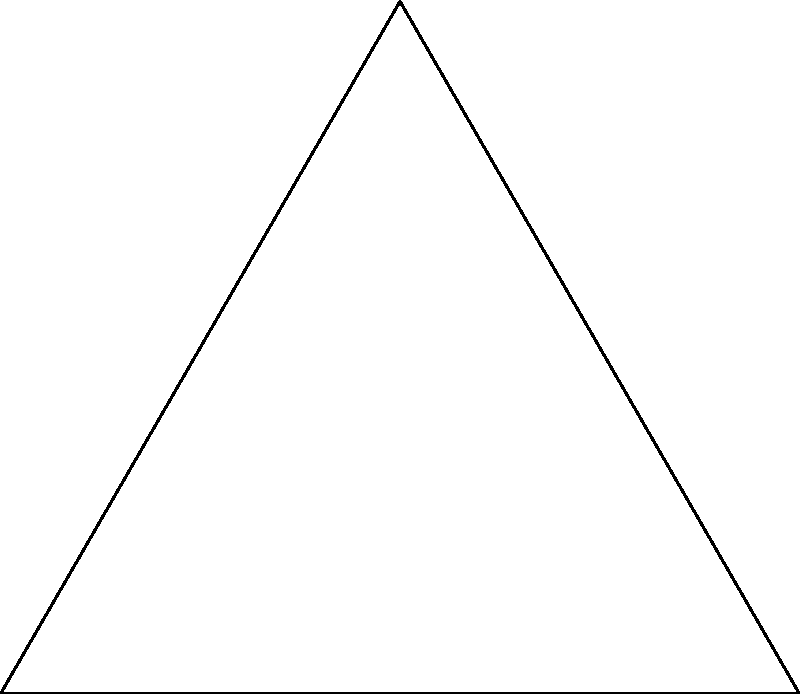In a basketball court represented by triangle ABC, three players are positioned at the vertices. Each player's defensive zone is a circle with a radius of 3 units. What is the area of the court that is covered by at least two defensive zones? To solve this problem, we'll follow these steps:

1) First, we need to calculate the area of intersection between each pair of circles:
   - Circles centered at A and B
   - Circles centered at B and C
   - Circles centered at A and C

2) The formula for the area of intersection of two circles with radius r and distance d between their centers is:

   $$A = 2r^2 \arccos(\frac{d}{2r}) - d\sqrt{r^2 - (\frac{d}{2})^2}$$

3) Let's calculate the distances:
   - AB = 6
   - BC = $\sqrt{3^2 + 5.2^2} \approx 6$
   - AC = $\sqrt{3^2 + 5.2^2} \approx 6$

4) Now, we can calculate the area of intersection for each pair:
   
   $$A = 2(3^2) \arccos(\frac{6}{2(3)}) - 6\sqrt{3^2 - (\frac{6}{2})^2} \approx 2.39$$

5) Since all distances are approximately equal, all intersections have the same area.

6) The total area covered by at least two zones is the sum of these three intersections:

   $$2.39 * 3 = 7.17$$

7) Note: This calculation doesn't account for any potential triple overlap, which would be negligible in this case due to the triangle's shape.
Answer: Approximately 7.17 square units 